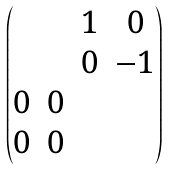<formula> <loc_0><loc_0><loc_500><loc_500>\begin{pmatrix} & & 1 & 0 \\ & & 0 & - 1 \\ 0 & 0 \\ 0 & 0 \end{pmatrix}</formula> 